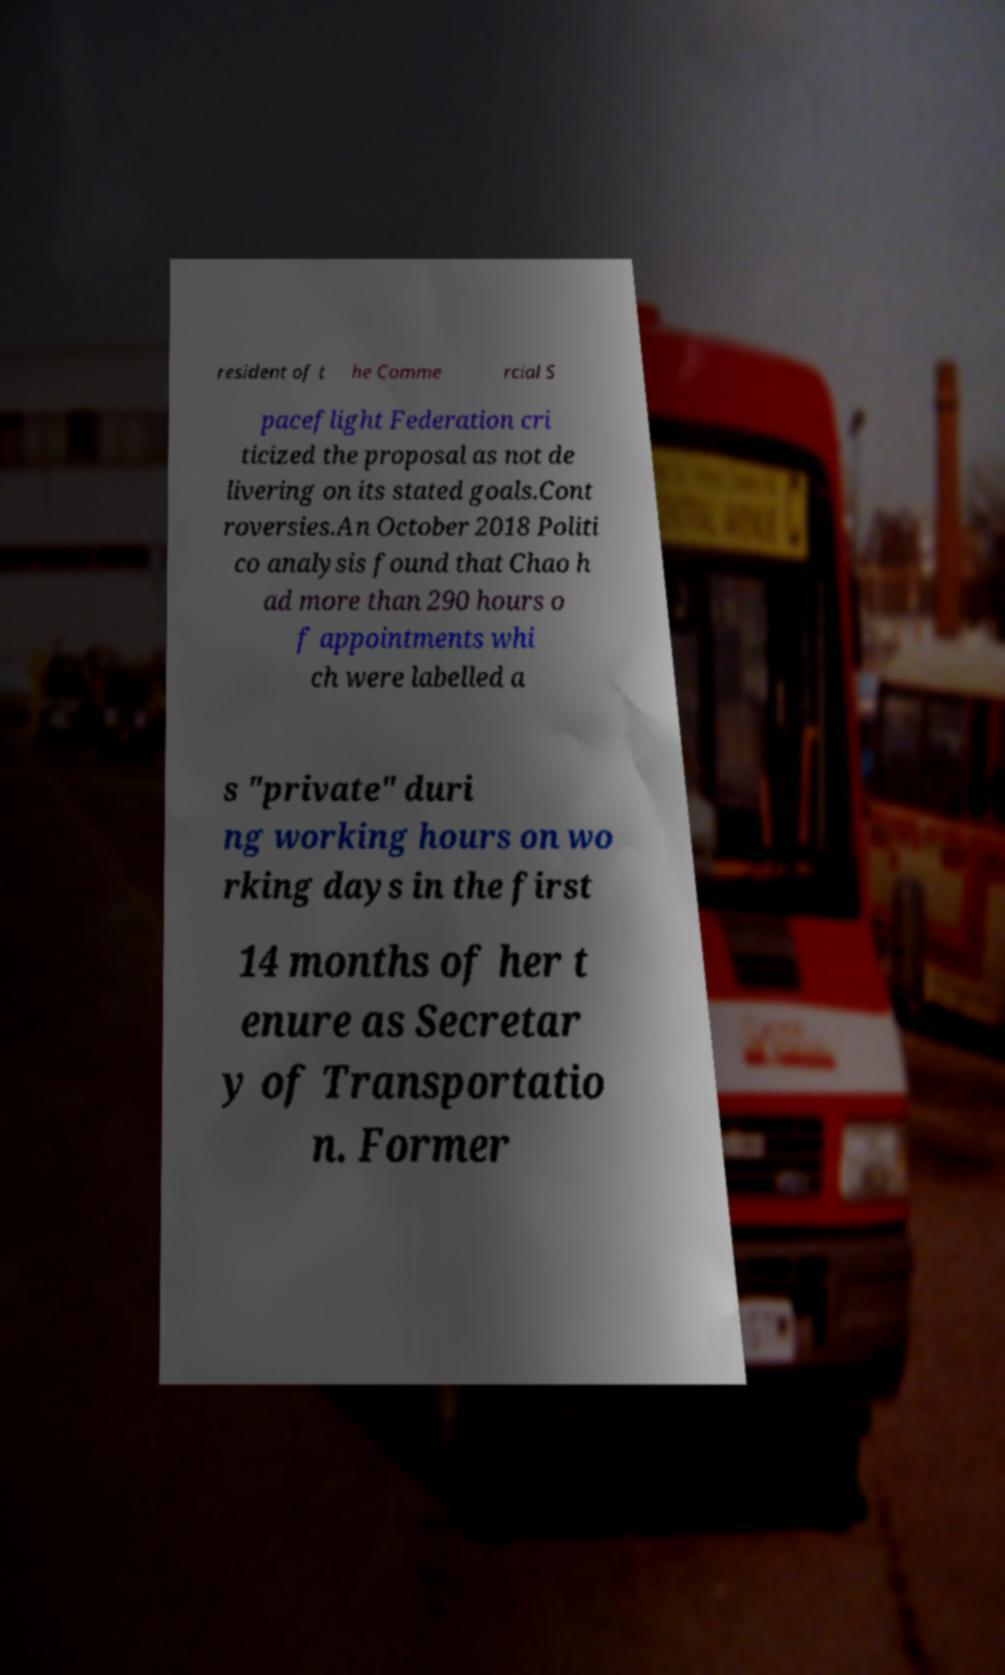Please identify and transcribe the text found in this image. resident of t he Comme rcial S paceflight Federation cri ticized the proposal as not de livering on its stated goals.Cont roversies.An October 2018 Politi co analysis found that Chao h ad more than 290 hours o f appointments whi ch were labelled a s "private" duri ng working hours on wo rking days in the first 14 months of her t enure as Secretar y of Transportatio n. Former 